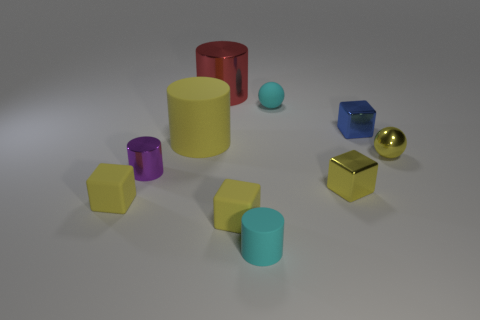Subtract all yellow cubes. How many were subtracted if there are1yellow cubes left? 2 Subtract all cyan spheres. How many yellow blocks are left? 3 Subtract 1 cubes. How many cubes are left? 3 Subtract all cubes. How many objects are left? 6 Subtract all large matte cylinders. Subtract all metallic objects. How many objects are left? 4 Add 5 red objects. How many red objects are left? 6 Add 7 big brown metallic objects. How many big brown metallic objects exist? 7 Subtract 0 green cylinders. How many objects are left? 10 